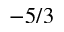<formula> <loc_0><loc_0><loc_500><loc_500>- 5 / 3</formula> 